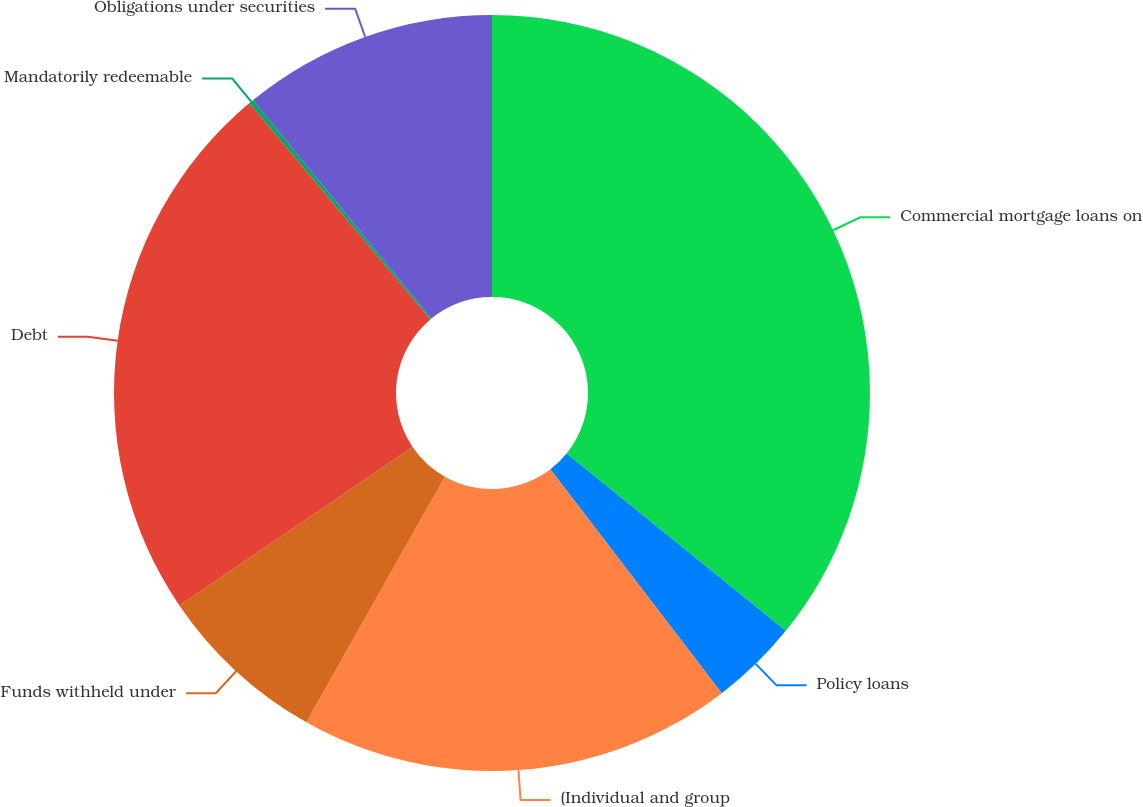<chart> <loc_0><loc_0><loc_500><loc_500><pie_chart><fcel>Commercial mortgage loans on<fcel>Policy loans<fcel>(Individual and group<fcel>Funds withheld under<fcel>Debt<fcel>Mandatorily redeemable<fcel>Obligations under securities<nl><fcel>35.83%<fcel>3.77%<fcel>18.57%<fcel>7.33%<fcel>23.41%<fcel>0.2%<fcel>10.89%<nl></chart> 